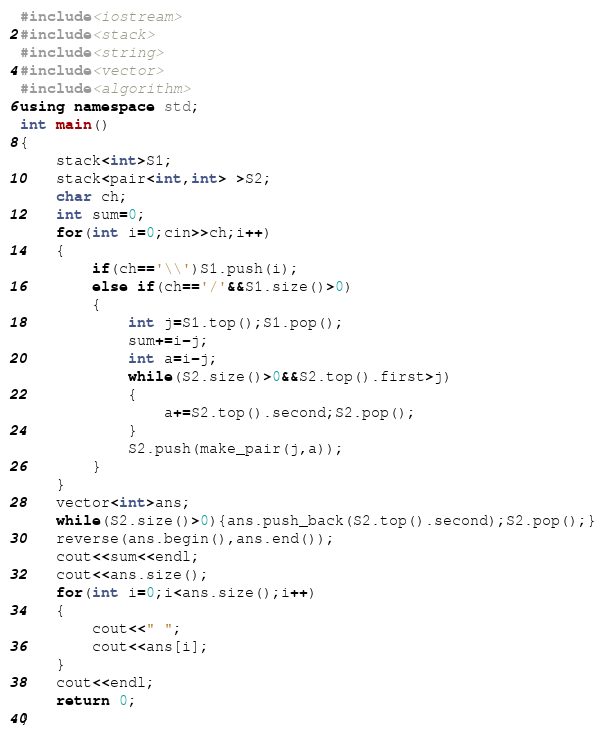Convert code to text. <code><loc_0><loc_0><loc_500><loc_500><_C++_>#include<iostream>
#include<stack>
#include<string>
#include<vector>
#include<algorithm>
using namespace std;
int main()
{
	stack<int>S1;
	stack<pair<int,int> >S2;
	char ch;
	int sum=0;
    for(int i=0;cin>>ch;i++)
    {
    	if(ch=='\\')S1.push(i);
    	else if(ch=='/'&&S1.size()>0)
    	{
    		int j=S1.top();S1.pop();
    		sum+=i-j;
    		int a=i-j;
    		while(S2.size()>0&&S2.top().first>j)
    		{
    			a+=S2.top().second;S2.pop();
    		}
    		S2.push(make_pair(j,a));
    	}
    }
    vector<int>ans;
    while(S2.size()>0){ans.push_back(S2.top().second);S2.pop();}
    reverse(ans.begin(),ans.end());
    cout<<sum<<endl;
    cout<<ans.size();
    for(int i=0;i<ans.size();i++)
    {
    	cout<<" ";
    	cout<<ans[i];
    }
    cout<<endl;
    return 0;
}</code> 